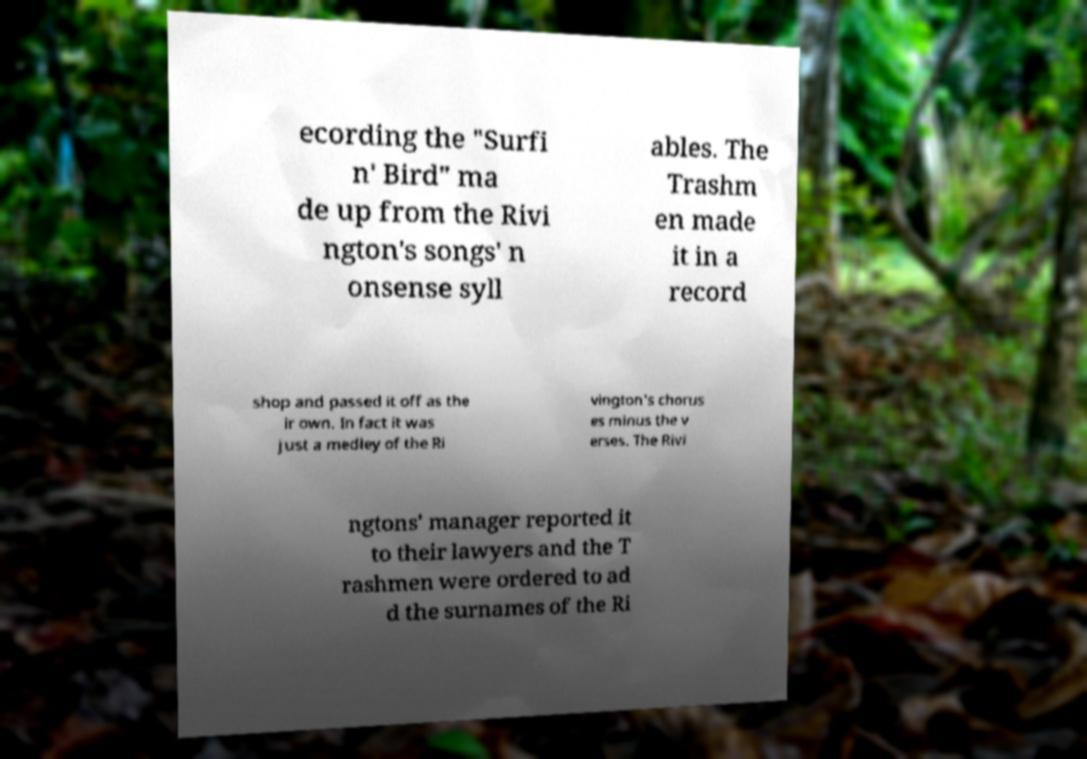Could you extract and type out the text from this image? ecording the "Surfi n' Bird" ma de up from the Rivi ngton's songs' n onsense syll ables. The Trashm en made it in a record shop and passed it off as the ir own. In fact it was just a medley of the Ri vington's chorus es minus the v erses. The Rivi ngtons' manager reported it to their lawyers and the T rashmen were ordered to ad d the surnames of the Ri 